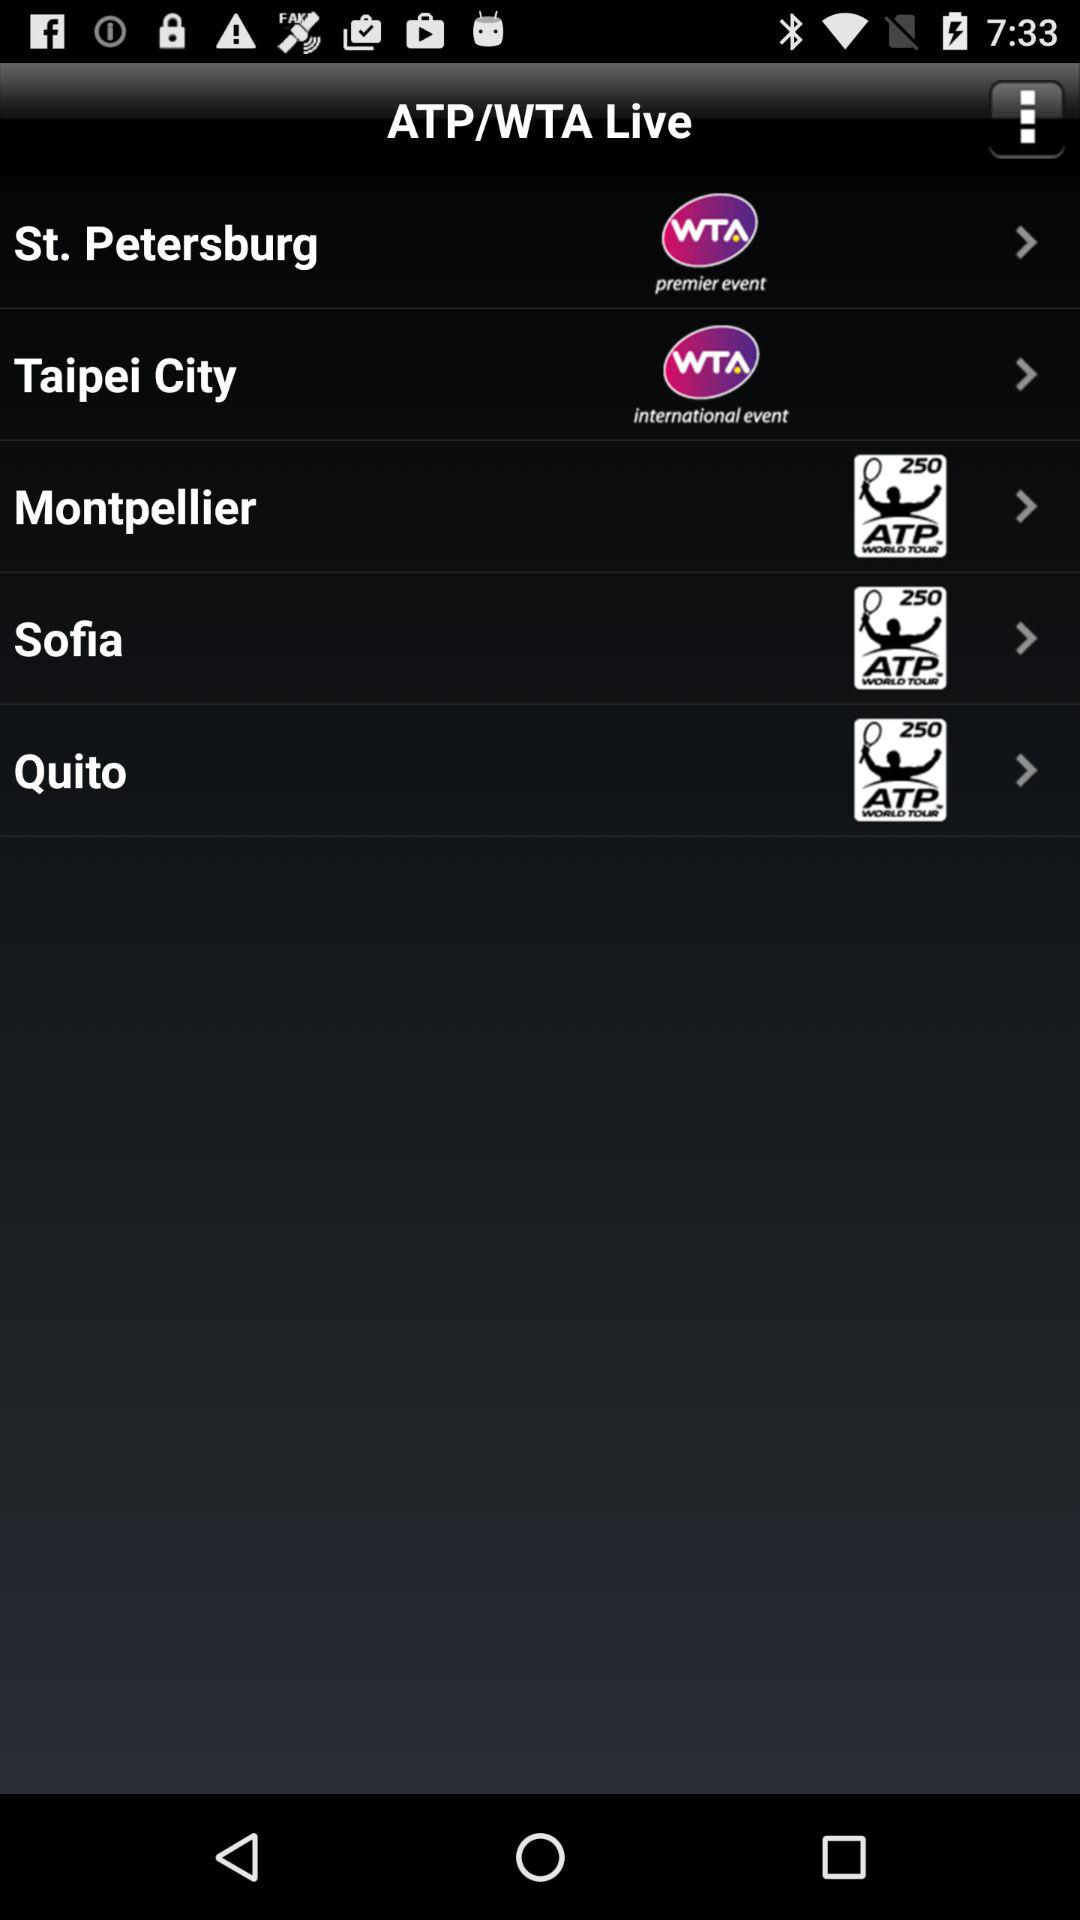How many events are of the 250 ATP WORLD TOUR type?
Answer the question using a single word or phrase. 3 